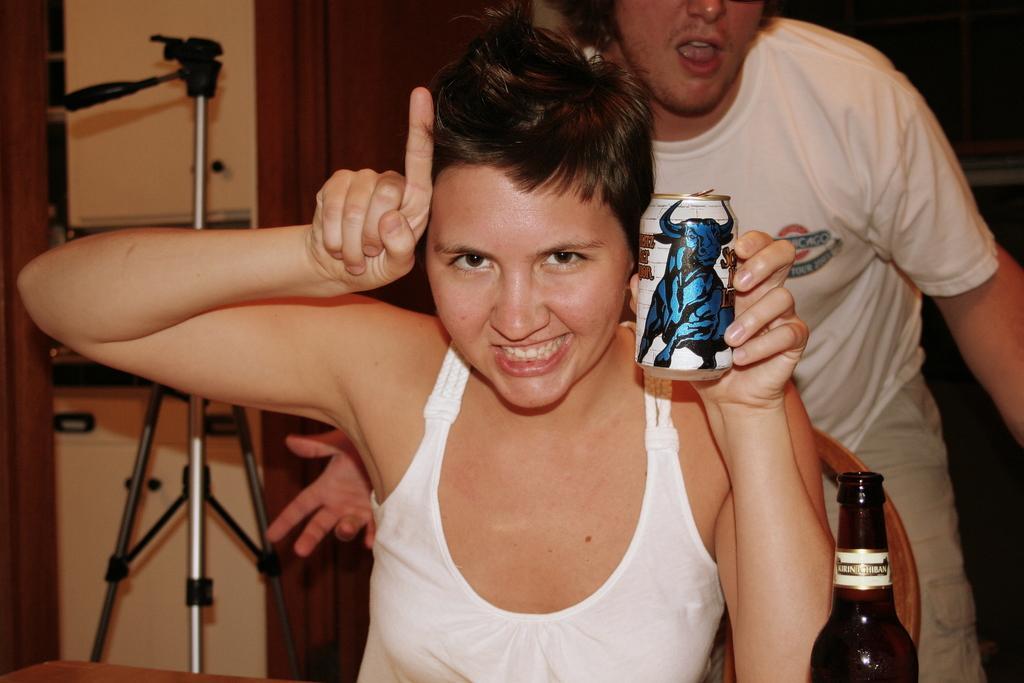Could you give a brief overview of what you see in this image? In the center of the image we can see a lady is sitting on a chair and holding a tin. At the bottom of the image we can see a table. On the table we can see a bottle. In the background of the image we can see the wall, stand, door and a man is bending. 